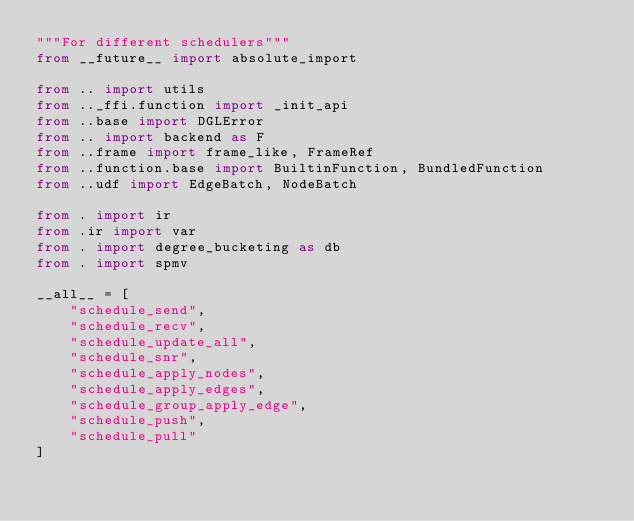<code> <loc_0><loc_0><loc_500><loc_500><_Python_>"""For different schedulers"""
from __future__ import absolute_import

from .. import utils
from .._ffi.function import _init_api
from ..base import DGLError
from .. import backend as F
from ..frame import frame_like, FrameRef
from ..function.base import BuiltinFunction, BundledFunction
from ..udf import EdgeBatch, NodeBatch

from . import ir
from .ir import var
from . import degree_bucketing as db
from . import spmv

__all__ = [
    "schedule_send",
    "schedule_recv",
    "schedule_update_all",
    "schedule_snr",
    "schedule_apply_nodes",
    "schedule_apply_edges",
    "schedule_group_apply_edge",
    "schedule_push",
    "schedule_pull"
]
</code> 